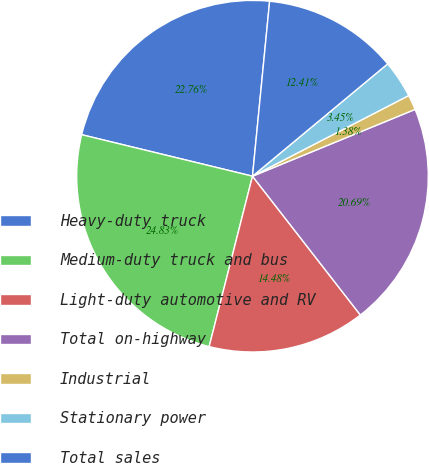Convert chart to OTSL. <chart><loc_0><loc_0><loc_500><loc_500><pie_chart><fcel>Heavy-duty truck<fcel>Medium-duty truck and bus<fcel>Light-duty automotive and RV<fcel>Total on-highway<fcel>Industrial<fcel>Stationary power<fcel>Total sales<nl><fcel>22.76%<fcel>24.83%<fcel>14.48%<fcel>20.69%<fcel>1.38%<fcel>3.45%<fcel>12.41%<nl></chart> 